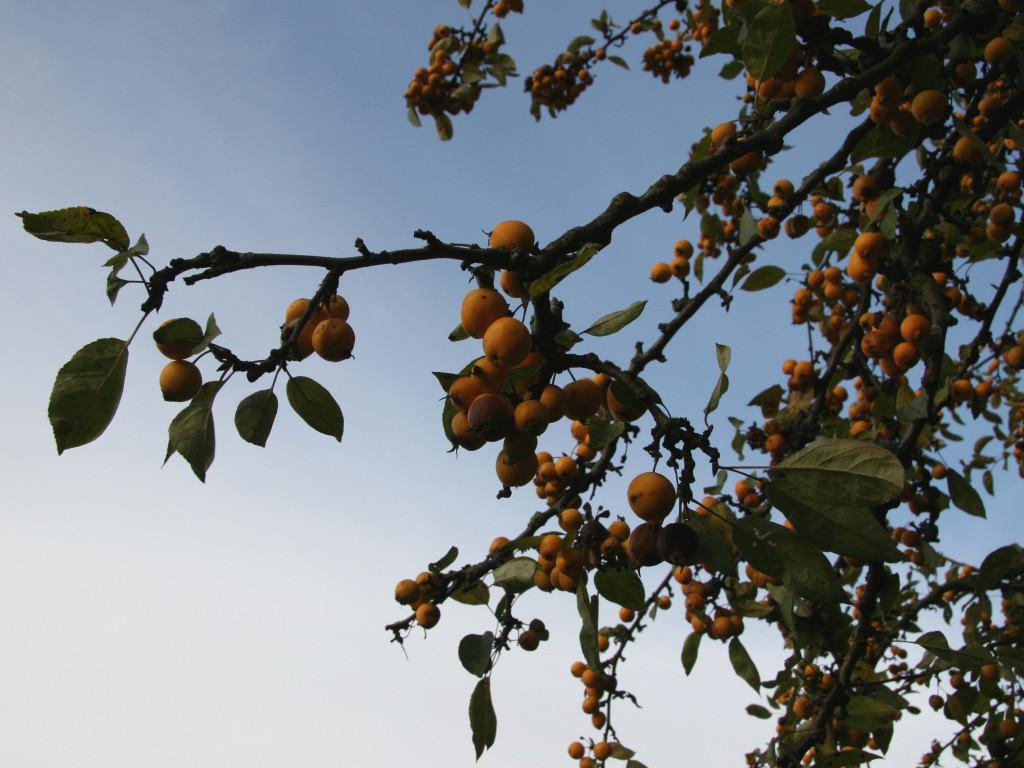What type of food items are present in the image? There are fruits in the image. What parts of the fruits are visible in the image? There are stems and leaves visible in the image. What is visible in the background of the image? The sky is visible in the background of the image. What type of stone can be seen being used to rake the clouds in the image? There is no stone or rake present in the image, and the clouds are not being manipulated in any way. 